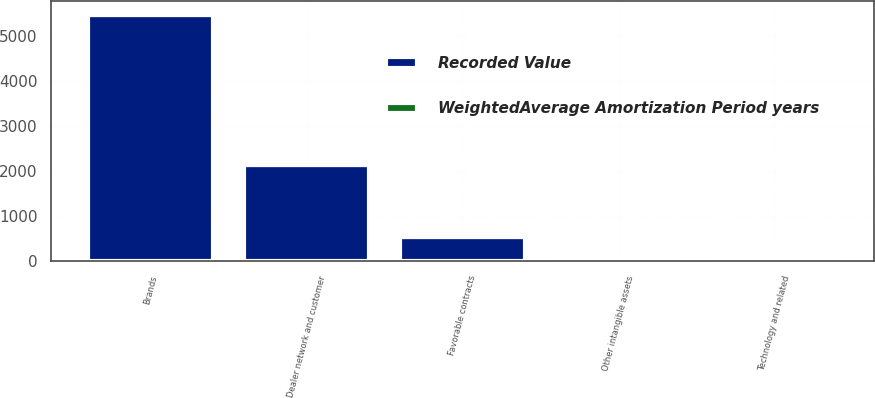<chart> <loc_0><loc_0><loc_500><loc_500><stacked_bar_chart><ecel><fcel>Technology and related<fcel>Brands<fcel>Dealer network and customer<fcel>Favorable contracts<fcel>Other intangible assets<nl><fcel>WeightedAverage Amortization Period years<fcel>5<fcel>38<fcel>21<fcel>28<fcel>3<nl><fcel>Recorded Value<fcel>28<fcel>5476<fcel>2149<fcel>543<fcel>17<nl></chart> 